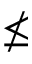<formula> <loc_0><loc_0><loc_500><loc_500>\nleq</formula> 